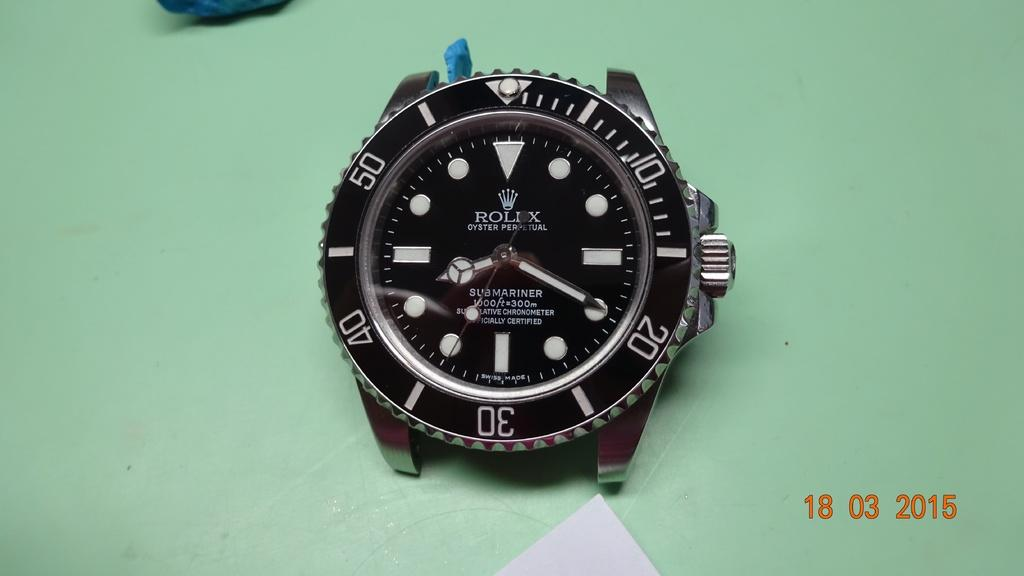What is the main subject of the image? The main subject of the image is a watch dial. What else can be seen in the image besides the watch dial? There is a paper on a green platform in the image. Are there any numbers visible in the image? Yes, there are numbers visible in the bottom right corner of the image. What type of dog is participating in the discussion in the image? There is no dog or discussion present in the image. 